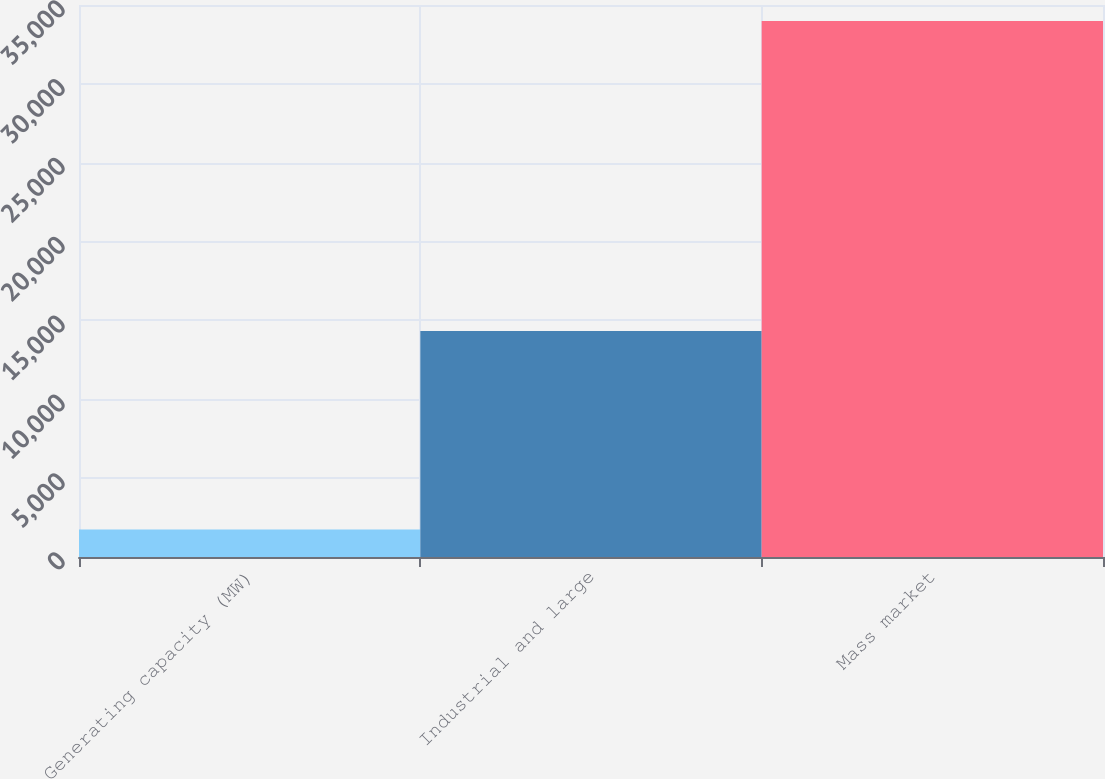Convert chart to OTSL. <chart><loc_0><loc_0><loc_500><loc_500><bar_chart><fcel>Generating capacity (MW)<fcel>Industrial and large<fcel>Mass market<nl><fcel>1739<fcel>14335<fcel>33979<nl></chart> 